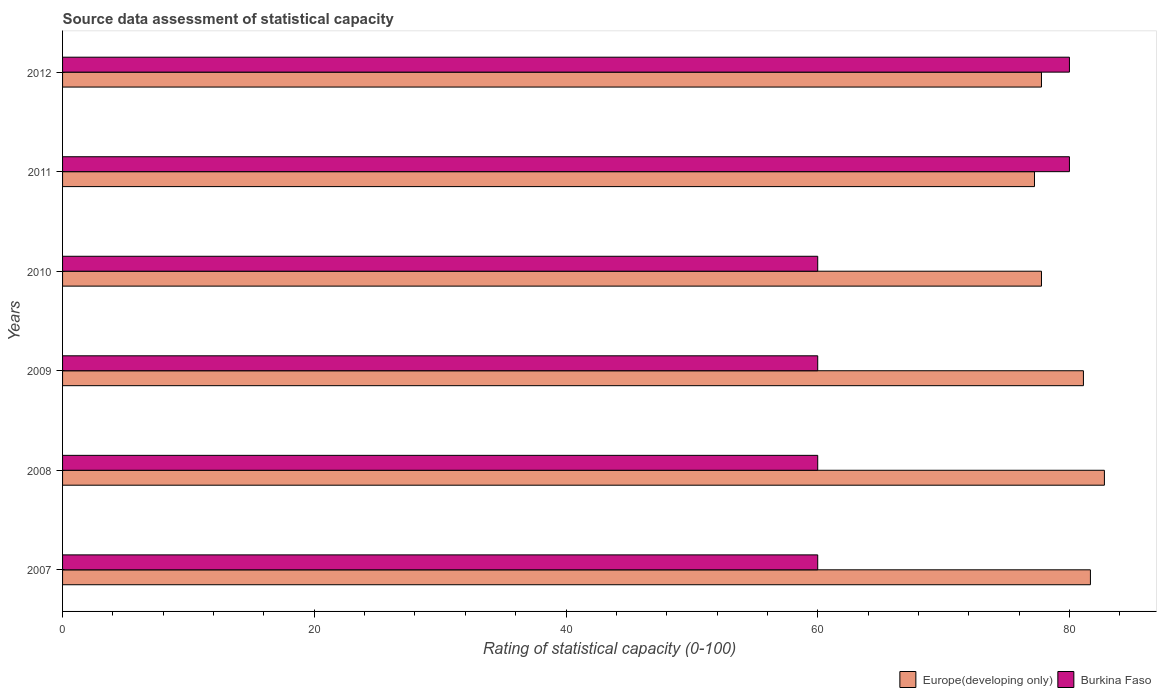How many different coloured bars are there?
Ensure brevity in your answer.  2. How many groups of bars are there?
Offer a terse response. 6. Are the number of bars per tick equal to the number of legend labels?
Give a very brief answer. Yes. How many bars are there on the 5th tick from the top?
Keep it short and to the point. 2. How many bars are there on the 6th tick from the bottom?
Your answer should be compact. 2. What is the rating of statistical capacity in Burkina Faso in 2008?
Provide a succinct answer. 60. Across all years, what is the maximum rating of statistical capacity in Burkina Faso?
Provide a short and direct response. 80. Across all years, what is the minimum rating of statistical capacity in Europe(developing only)?
Provide a succinct answer. 77.22. In which year was the rating of statistical capacity in Burkina Faso minimum?
Your answer should be compact. 2007. What is the total rating of statistical capacity in Burkina Faso in the graph?
Ensure brevity in your answer.  400. What is the difference between the rating of statistical capacity in Burkina Faso in 2009 and that in 2011?
Your response must be concise. -20. What is the difference between the rating of statistical capacity in Europe(developing only) in 2009 and the rating of statistical capacity in Burkina Faso in 2007?
Give a very brief answer. 21.11. What is the average rating of statistical capacity in Europe(developing only) per year?
Provide a short and direct response. 79.72. In the year 2011, what is the difference between the rating of statistical capacity in Burkina Faso and rating of statistical capacity in Europe(developing only)?
Make the answer very short. 2.78. In how many years, is the rating of statistical capacity in Burkina Faso greater than 4 ?
Offer a very short reply. 6. What is the ratio of the rating of statistical capacity in Burkina Faso in 2010 to that in 2012?
Make the answer very short. 0.75. Is the difference between the rating of statistical capacity in Burkina Faso in 2008 and 2010 greater than the difference between the rating of statistical capacity in Europe(developing only) in 2008 and 2010?
Your response must be concise. No. What is the difference between the highest and the second highest rating of statistical capacity in Europe(developing only)?
Ensure brevity in your answer.  1.11. What is the difference between the highest and the lowest rating of statistical capacity in Burkina Faso?
Your answer should be compact. 20. In how many years, is the rating of statistical capacity in Europe(developing only) greater than the average rating of statistical capacity in Europe(developing only) taken over all years?
Your response must be concise. 3. Is the sum of the rating of statistical capacity in Burkina Faso in 2007 and 2011 greater than the maximum rating of statistical capacity in Europe(developing only) across all years?
Your answer should be compact. Yes. What does the 1st bar from the top in 2009 represents?
Your response must be concise. Burkina Faso. What does the 1st bar from the bottom in 2012 represents?
Keep it short and to the point. Europe(developing only). How many bars are there?
Ensure brevity in your answer.  12. Are all the bars in the graph horizontal?
Provide a short and direct response. Yes. How many years are there in the graph?
Make the answer very short. 6. Does the graph contain any zero values?
Give a very brief answer. No. Does the graph contain grids?
Provide a short and direct response. No. How are the legend labels stacked?
Offer a terse response. Horizontal. What is the title of the graph?
Give a very brief answer. Source data assessment of statistical capacity. Does "Zambia" appear as one of the legend labels in the graph?
Make the answer very short. No. What is the label or title of the X-axis?
Your answer should be very brief. Rating of statistical capacity (0-100). What is the label or title of the Y-axis?
Offer a very short reply. Years. What is the Rating of statistical capacity (0-100) in Europe(developing only) in 2007?
Give a very brief answer. 81.67. What is the Rating of statistical capacity (0-100) of Burkina Faso in 2007?
Ensure brevity in your answer.  60. What is the Rating of statistical capacity (0-100) of Europe(developing only) in 2008?
Offer a terse response. 82.78. What is the Rating of statistical capacity (0-100) of Burkina Faso in 2008?
Your answer should be very brief. 60. What is the Rating of statistical capacity (0-100) in Europe(developing only) in 2009?
Give a very brief answer. 81.11. What is the Rating of statistical capacity (0-100) of Burkina Faso in 2009?
Provide a short and direct response. 60. What is the Rating of statistical capacity (0-100) in Europe(developing only) in 2010?
Offer a very short reply. 77.78. What is the Rating of statistical capacity (0-100) of Europe(developing only) in 2011?
Your answer should be very brief. 77.22. What is the Rating of statistical capacity (0-100) of Burkina Faso in 2011?
Keep it short and to the point. 80. What is the Rating of statistical capacity (0-100) of Europe(developing only) in 2012?
Ensure brevity in your answer.  77.78. Across all years, what is the maximum Rating of statistical capacity (0-100) of Europe(developing only)?
Give a very brief answer. 82.78. Across all years, what is the minimum Rating of statistical capacity (0-100) of Europe(developing only)?
Make the answer very short. 77.22. Across all years, what is the minimum Rating of statistical capacity (0-100) of Burkina Faso?
Your response must be concise. 60. What is the total Rating of statistical capacity (0-100) of Europe(developing only) in the graph?
Ensure brevity in your answer.  478.33. What is the difference between the Rating of statistical capacity (0-100) of Europe(developing only) in 2007 and that in 2008?
Ensure brevity in your answer.  -1.11. What is the difference between the Rating of statistical capacity (0-100) of Europe(developing only) in 2007 and that in 2009?
Keep it short and to the point. 0.56. What is the difference between the Rating of statistical capacity (0-100) of Europe(developing only) in 2007 and that in 2010?
Your answer should be compact. 3.89. What is the difference between the Rating of statistical capacity (0-100) of Burkina Faso in 2007 and that in 2010?
Ensure brevity in your answer.  0. What is the difference between the Rating of statistical capacity (0-100) in Europe(developing only) in 2007 and that in 2011?
Your answer should be very brief. 4.44. What is the difference between the Rating of statistical capacity (0-100) in Burkina Faso in 2007 and that in 2011?
Your answer should be compact. -20. What is the difference between the Rating of statistical capacity (0-100) of Europe(developing only) in 2007 and that in 2012?
Provide a succinct answer. 3.89. What is the difference between the Rating of statistical capacity (0-100) in Europe(developing only) in 2008 and that in 2009?
Offer a very short reply. 1.67. What is the difference between the Rating of statistical capacity (0-100) of Europe(developing only) in 2008 and that in 2010?
Your answer should be very brief. 5. What is the difference between the Rating of statistical capacity (0-100) of Burkina Faso in 2008 and that in 2010?
Keep it short and to the point. 0. What is the difference between the Rating of statistical capacity (0-100) of Europe(developing only) in 2008 and that in 2011?
Ensure brevity in your answer.  5.56. What is the difference between the Rating of statistical capacity (0-100) in Burkina Faso in 2008 and that in 2011?
Give a very brief answer. -20. What is the difference between the Rating of statistical capacity (0-100) of Europe(developing only) in 2009 and that in 2011?
Your answer should be compact. 3.89. What is the difference between the Rating of statistical capacity (0-100) in Europe(developing only) in 2010 and that in 2011?
Make the answer very short. 0.56. What is the difference between the Rating of statistical capacity (0-100) of Burkina Faso in 2010 and that in 2012?
Give a very brief answer. -20. What is the difference between the Rating of statistical capacity (0-100) in Europe(developing only) in 2011 and that in 2012?
Keep it short and to the point. -0.56. What is the difference between the Rating of statistical capacity (0-100) of Burkina Faso in 2011 and that in 2012?
Provide a short and direct response. 0. What is the difference between the Rating of statistical capacity (0-100) of Europe(developing only) in 2007 and the Rating of statistical capacity (0-100) of Burkina Faso in 2008?
Provide a succinct answer. 21.67. What is the difference between the Rating of statistical capacity (0-100) of Europe(developing only) in 2007 and the Rating of statistical capacity (0-100) of Burkina Faso in 2009?
Keep it short and to the point. 21.67. What is the difference between the Rating of statistical capacity (0-100) in Europe(developing only) in 2007 and the Rating of statistical capacity (0-100) in Burkina Faso in 2010?
Your response must be concise. 21.67. What is the difference between the Rating of statistical capacity (0-100) in Europe(developing only) in 2008 and the Rating of statistical capacity (0-100) in Burkina Faso in 2009?
Your answer should be compact. 22.78. What is the difference between the Rating of statistical capacity (0-100) in Europe(developing only) in 2008 and the Rating of statistical capacity (0-100) in Burkina Faso in 2010?
Your answer should be very brief. 22.78. What is the difference between the Rating of statistical capacity (0-100) of Europe(developing only) in 2008 and the Rating of statistical capacity (0-100) of Burkina Faso in 2011?
Ensure brevity in your answer.  2.78. What is the difference between the Rating of statistical capacity (0-100) in Europe(developing only) in 2008 and the Rating of statistical capacity (0-100) in Burkina Faso in 2012?
Provide a short and direct response. 2.78. What is the difference between the Rating of statistical capacity (0-100) in Europe(developing only) in 2009 and the Rating of statistical capacity (0-100) in Burkina Faso in 2010?
Provide a short and direct response. 21.11. What is the difference between the Rating of statistical capacity (0-100) of Europe(developing only) in 2010 and the Rating of statistical capacity (0-100) of Burkina Faso in 2011?
Your response must be concise. -2.22. What is the difference between the Rating of statistical capacity (0-100) of Europe(developing only) in 2010 and the Rating of statistical capacity (0-100) of Burkina Faso in 2012?
Your response must be concise. -2.22. What is the difference between the Rating of statistical capacity (0-100) of Europe(developing only) in 2011 and the Rating of statistical capacity (0-100) of Burkina Faso in 2012?
Offer a very short reply. -2.78. What is the average Rating of statistical capacity (0-100) of Europe(developing only) per year?
Give a very brief answer. 79.72. What is the average Rating of statistical capacity (0-100) of Burkina Faso per year?
Your answer should be compact. 66.67. In the year 2007, what is the difference between the Rating of statistical capacity (0-100) of Europe(developing only) and Rating of statistical capacity (0-100) of Burkina Faso?
Provide a short and direct response. 21.67. In the year 2008, what is the difference between the Rating of statistical capacity (0-100) of Europe(developing only) and Rating of statistical capacity (0-100) of Burkina Faso?
Offer a very short reply. 22.78. In the year 2009, what is the difference between the Rating of statistical capacity (0-100) in Europe(developing only) and Rating of statistical capacity (0-100) in Burkina Faso?
Provide a succinct answer. 21.11. In the year 2010, what is the difference between the Rating of statistical capacity (0-100) of Europe(developing only) and Rating of statistical capacity (0-100) of Burkina Faso?
Your response must be concise. 17.78. In the year 2011, what is the difference between the Rating of statistical capacity (0-100) in Europe(developing only) and Rating of statistical capacity (0-100) in Burkina Faso?
Offer a terse response. -2.78. In the year 2012, what is the difference between the Rating of statistical capacity (0-100) in Europe(developing only) and Rating of statistical capacity (0-100) in Burkina Faso?
Offer a very short reply. -2.22. What is the ratio of the Rating of statistical capacity (0-100) of Europe(developing only) in 2007 to that in 2008?
Your answer should be compact. 0.99. What is the ratio of the Rating of statistical capacity (0-100) in Europe(developing only) in 2007 to that in 2009?
Offer a terse response. 1.01. What is the ratio of the Rating of statistical capacity (0-100) in Europe(developing only) in 2007 to that in 2010?
Offer a terse response. 1.05. What is the ratio of the Rating of statistical capacity (0-100) in Europe(developing only) in 2007 to that in 2011?
Provide a succinct answer. 1.06. What is the ratio of the Rating of statistical capacity (0-100) of Europe(developing only) in 2007 to that in 2012?
Your answer should be compact. 1.05. What is the ratio of the Rating of statistical capacity (0-100) of Europe(developing only) in 2008 to that in 2009?
Your response must be concise. 1.02. What is the ratio of the Rating of statistical capacity (0-100) of Burkina Faso in 2008 to that in 2009?
Provide a succinct answer. 1. What is the ratio of the Rating of statistical capacity (0-100) in Europe(developing only) in 2008 to that in 2010?
Ensure brevity in your answer.  1.06. What is the ratio of the Rating of statistical capacity (0-100) in Europe(developing only) in 2008 to that in 2011?
Your response must be concise. 1.07. What is the ratio of the Rating of statistical capacity (0-100) of Burkina Faso in 2008 to that in 2011?
Provide a succinct answer. 0.75. What is the ratio of the Rating of statistical capacity (0-100) of Europe(developing only) in 2008 to that in 2012?
Make the answer very short. 1.06. What is the ratio of the Rating of statistical capacity (0-100) in Europe(developing only) in 2009 to that in 2010?
Offer a terse response. 1.04. What is the ratio of the Rating of statistical capacity (0-100) of Europe(developing only) in 2009 to that in 2011?
Give a very brief answer. 1.05. What is the ratio of the Rating of statistical capacity (0-100) of Europe(developing only) in 2009 to that in 2012?
Your answer should be very brief. 1.04. What is the ratio of the Rating of statistical capacity (0-100) of Burkina Faso in 2010 to that in 2011?
Your response must be concise. 0.75. What is the ratio of the Rating of statistical capacity (0-100) in Burkina Faso in 2010 to that in 2012?
Offer a very short reply. 0.75. What is the difference between the highest and the second highest Rating of statistical capacity (0-100) of Europe(developing only)?
Offer a very short reply. 1.11. What is the difference between the highest and the lowest Rating of statistical capacity (0-100) of Europe(developing only)?
Give a very brief answer. 5.56. What is the difference between the highest and the lowest Rating of statistical capacity (0-100) of Burkina Faso?
Give a very brief answer. 20. 